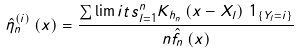<formula> <loc_0><loc_0><loc_500><loc_500>& \hat { \eta } _ { n } ^ { ( i ) } \left ( x \right ) = \frac { \sum \lim i t s _ { l = 1 } ^ { n } { K _ { h _ { n } } \left ( { x - { X _ { l } } } \right ) } { \ 1 } _ { \{ Y _ { l } = i \} } } { n { \hat { f } } _ { n } \left ( x \right ) }</formula> 